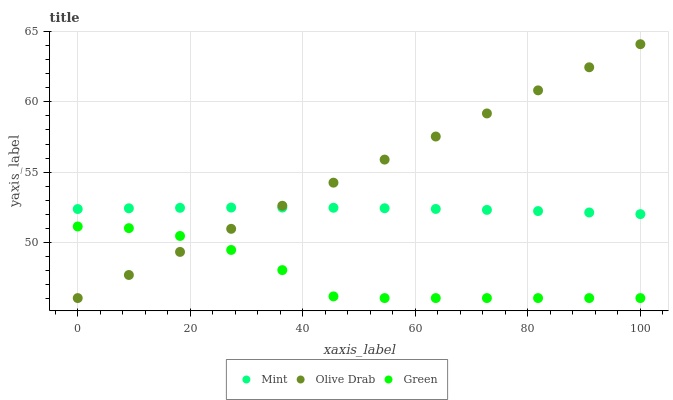Does Green have the minimum area under the curve?
Answer yes or no. Yes. Does Olive Drab have the maximum area under the curve?
Answer yes or no. Yes. Does Mint have the minimum area under the curve?
Answer yes or no. No. Does Mint have the maximum area under the curve?
Answer yes or no. No. Is Olive Drab the smoothest?
Answer yes or no. Yes. Is Green the roughest?
Answer yes or no. Yes. Is Mint the smoothest?
Answer yes or no. No. Is Mint the roughest?
Answer yes or no. No. Does Green have the lowest value?
Answer yes or no. Yes. Does Mint have the lowest value?
Answer yes or no. No. Does Olive Drab have the highest value?
Answer yes or no. Yes. Does Mint have the highest value?
Answer yes or no. No. Is Green less than Mint?
Answer yes or no. Yes. Is Mint greater than Green?
Answer yes or no. Yes. Does Green intersect Olive Drab?
Answer yes or no. Yes. Is Green less than Olive Drab?
Answer yes or no. No. Is Green greater than Olive Drab?
Answer yes or no. No. Does Green intersect Mint?
Answer yes or no. No. 